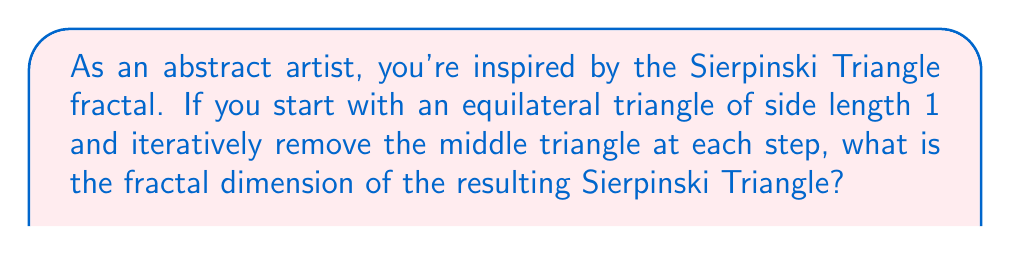Could you help me with this problem? Let's approach this step-by-step:

1) The Sierpinski Triangle is a self-similar fractal. At each iteration, we're creating a new shape that's composed of three copies of the previous iteration, each scaled down by a factor of 1/2.

2) For self-similar fractals, we can use the formula:

   $$D = \frac{\log N}{\log (1/r)}$$

   Where:
   - $D$ is the fractal dimension
   - $N$ is the number of self-similar pieces
   - $r$ is the scaling factor

3) In our case:
   - $N = 3$ (we have 3 smaller triangles in each iteration)
   - $r = 1/2$ (each smaller triangle has half the side length of the previous one)

4) Let's substitute these values:

   $$D = \frac{\log 3}{\log (1/(1/2))} = \frac{\log 3}{\log 2}$$

5) We can calculate this:

   $$D = \frac{\log 3}{\log 2} \approx 1.5849625007$$

6) This result makes sense intuitively. The Sierpinski Triangle is more complex than a one-dimensional line (dimension 1) but doesn't quite fill a two-dimensional plane (dimension 2).
Answer: $\frac{\log 3}{\log 2} \approx 1.5849625007$ 